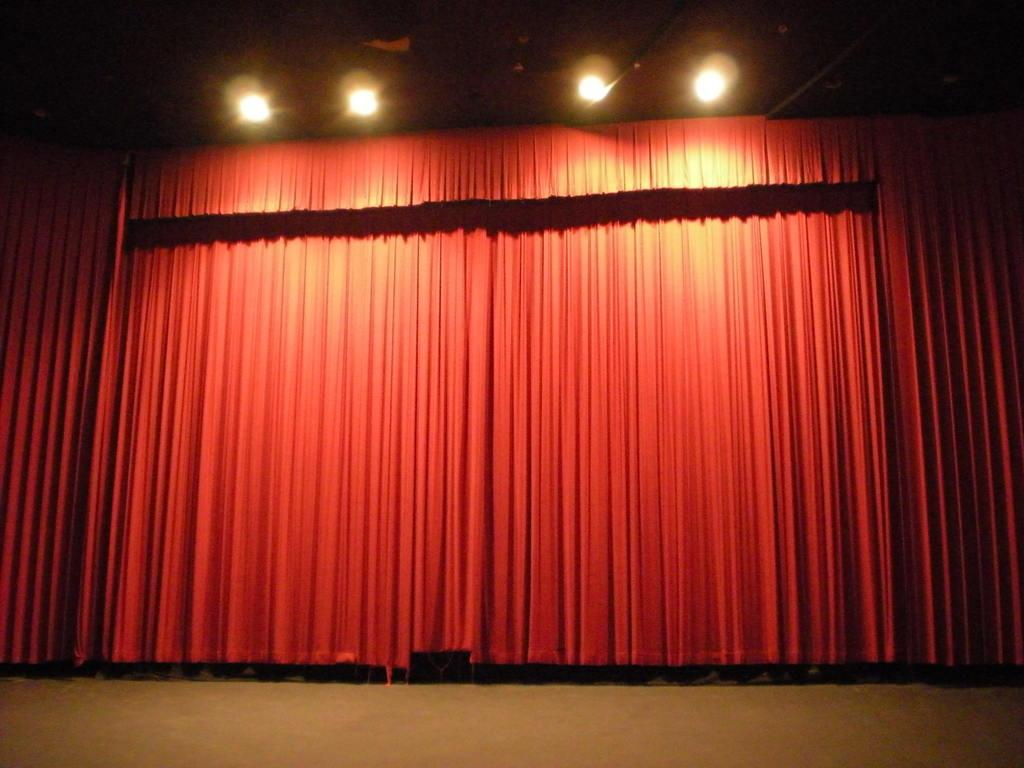What color are the curtains in the image? There are red color curtains in the image. Can you describe the lights in the image? There are lights at the top in the image. What type of authority is depicted in the image? There is no authority figure present in the image. How many cars are visible in the image? There are no cars present in the image. What type of selection process is shown taking place in the image? There is no selection process depicted in the image. 